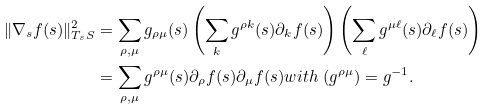Convert formula to latex. <formula><loc_0><loc_0><loc_500><loc_500>\| \nabla _ { s } f ( s ) \| _ { T _ { s } S } ^ { 2 } & = \sum _ { \rho , \mu } g _ { \rho \mu } ( s ) \left ( \sum _ { k } g ^ { \rho k } ( s ) \partial _ { k } f ( s ) \right ) \left ( \sum _ { \ell } g ^ { \mu \ell } ( s ) \partial _ { \ell } f ( s ) \right ) \\ & = \sum _ { \rho , \mu } g ^ { \rho \mu } ( s ) \partial _ { \rho } f ( s ) \partial _ { \mu } f ( s ) w i t h \ ( g ^ { \rho \mu } ) = g ^ { - 1 } .</formula> 